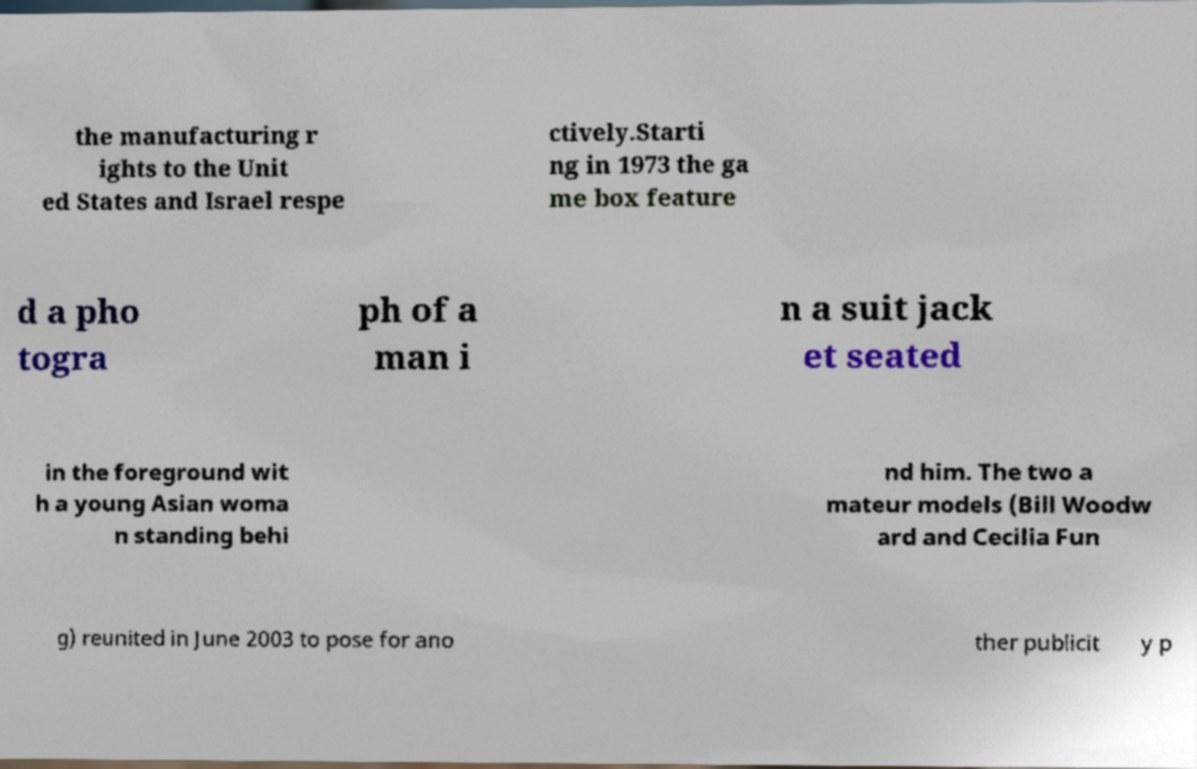Can you accurately transcribe the text from the provided image for me? the manufacturing r ights to the Unit ed States and Israel respe ctively.Starti ng in 1973 the ga me box feature d a pho togra ph of a man i n a suit jack et seated in the foreground wit h a young Asian woma n standing behi nd him. The two a mateur models (Bill Woodw ard and Cecilia Fun g) reunited in June 2003 to pose for ano ther publicit y p 